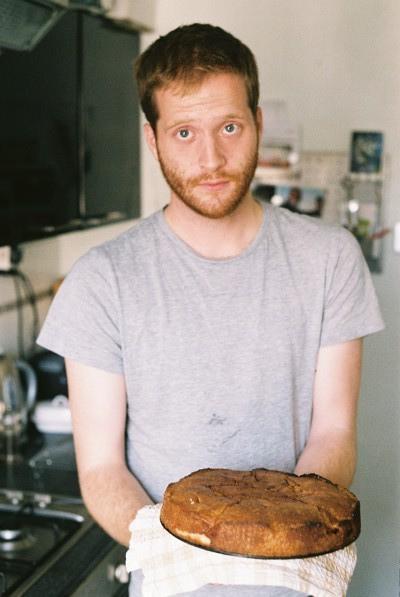Is the given caption "The oven is in front of the person." fitting for the image?
Answer yes or no. No. Does the caption "The cake is in front of the person." correctly depict the image?
Answer yes or no. Yes. 